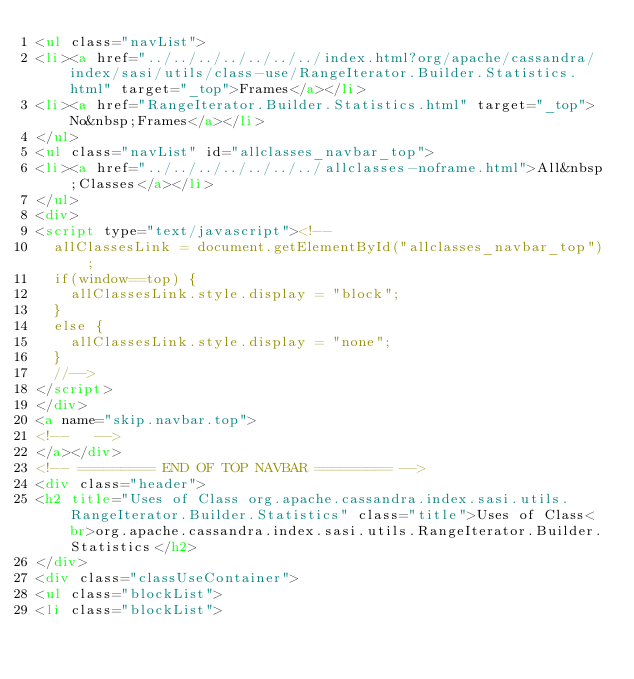Convert code to text. <code><loc_0><loc_0><loc_500><loc_500><_HTML_><ul class="navList">
<li><a href="../../../../../../../index.html?org/apache/cassandra/index/sasi/utils/class-use/RangeIterator.Builder.Statistics.html" target="_top">Frames</a></li>
<li><a href="RangeIterator.Builder.Statistics.html" target="_top">No&nbsp;Frames</a></li>
</ul>
<ul class="navList" id="allclasses_navbar_top">
<li><a href="../../../../../../../allclasses-noframe.html">All&nbsp;Classes</a></li>
</ul>
<div>
<script type="text/javascript"><!--
  allClassesLink = document.getElementById("allclasses_navbar_top");
  if(window==top) {
    allClassesLink.style.display = "block";
  }
  else {
    allClassesLink.style.display = "none";
  }
  //-->
</script>
</div>
<a name="skip.navbar.top">
<!--   -->
</a></div>
<!-- ========= END OF TOP NAVBAR ========= -->
<div class="header">
<h2 title="Uses of Class org.apache.cassandra.index.sasi.utils.RangeIterator.Builder.Statistics" class="title">Uses of Class<br>org.apache.cassandra.index.sasi.utils.RangeIterator.Builder.Statistics</h2>
</div>
<div class="classUseContainer">
<ul class="blockList">
<li class="blockList"></code> 